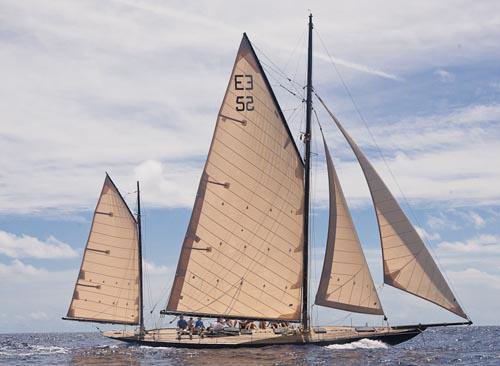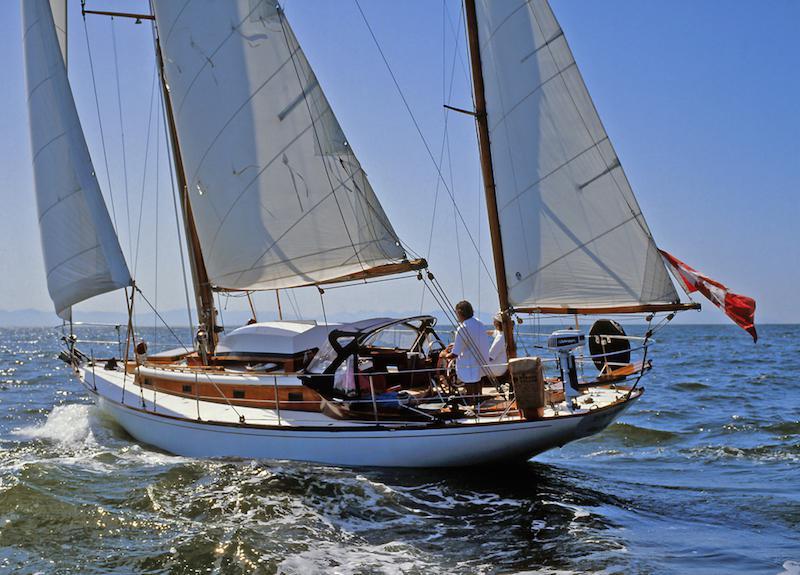The first image is the image on the left, the second image is the image on the right. For the images shown, is this caption "There’s a single sailboat with at least three brick colored sail deployed to help the boat move." true? Answer yes or no. No. The first image is the image on the left, the second image is the image on the right. For the images shown, is this caption "Sailboat with three white sails has no more than two clouds in the sky." true? Answer yes or no. Yes. 